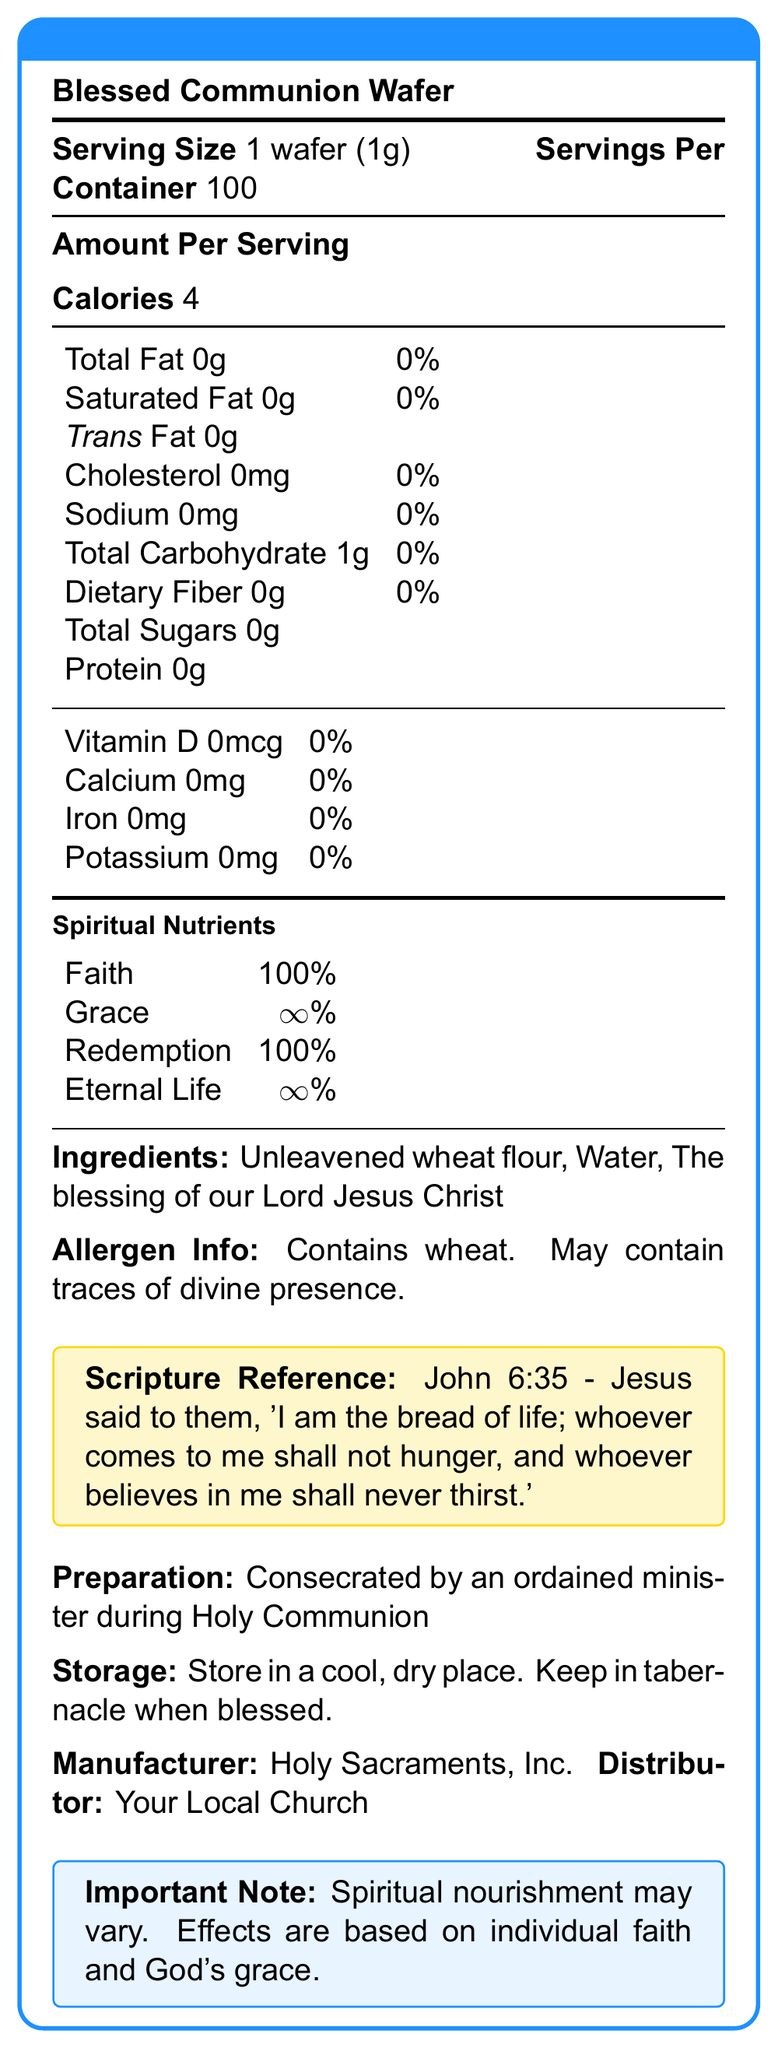what is the serving size of the Blessed Communion Wafer? The serving size is clearly mentioned in the document as 1 wafer (1g).
Answer: 1 wafer (1g) how many servings are there per container? The document states that there are 100 servings per container.
Answer: 100 how many calories are there per serving? The amount of calories per serving is given as 4.
Answer: 4 which vitamin is present in the Blessed Communion Wafer? The document lists all vitamins with a content of 0, indicating no vitamins are present.
Answer: None what is the % Daily Value of sodium per serving? The document shows that the % Daily Value of sodium per serving is 0%.
Answer: 0% what are the ingredients of the Blessed Communion Wafer? The ingredients are explicitly listed in the document.
Answer: Unleavened wheat flour, Water, The blessing of our Lord Jesus Christ which spiritual nutrient has the highest percentage? A. Faith B. Grace C. Redemption D. Eternal Life The document lists Grace with an ∞% percentage, which is the highest.
Answer: B. Grace how is the Blessed Communion Wafer prepared? A. By Baking B. By Boiling C. Consecration by an ordained minister D. Fermentation The document states that the wafer is consecrated by an ordained minister during Holy Communion.
Answer: C. Consecration by an ordained minister what is the scripture reference associated with the Blessed Communion Wafer? A. John 6:35 B. Matthew 5:9 C. Luke 22:19 D. Mark 14:22 The specified scripture reference in the document is John 6:35.
Answer: A. John 6:35 is the Blessed Communion Wafer free from allergens? The document mentions that it contains wheat and may contain traces of divine presence.
Answer: No does the Blessed Communion Wafer have any protein content? According to the document, the protein content per serving is 0g.
Answer: No what is the total carbohydrate content per serving? The total carbohydrate content per serving is listed as 1g.
Answer: 1g how should the Blessed Communion Wafer be stored once blessed? The document advises storing in a tabernacle when blessed.
Answer: Keep in tabernacle summarize the main idea of the document. The document is an overview of the Blessed Communion Wafer, describing its physical and spiritual components, and providing guidelines on preparation and storage while highlighting its religious significance.
Answer: The document provides detailed nutritional and spiritual information about the Blessed Communion Wafer, including serving size, ingredients, preparation, storage, and associated scripture reference. It emphasizes the spiritual benefits such as Faith, Grace, Redemption, and Eternal Life. who is the distributor of the Blessed Communion Wafer? The document mentions that the distributor is Your Local Church.
Answer: Your Local Church what is the % daily value of total fat? The document lists the % daily value of total fat as 0%.
Answer: 0% what does the document say about the variability in spiritual nourishment? The document includes a note that spiritual nourishment may vary depending on individual faith and God's grace.
Answer: Spiritual nourishment may vary. Effects are based on individual faith and God's grace. is there any information on where the Blessed Communion Wafer is manufactured? The document mentions that the manufacturer is Holy Sacraments, Inc.
Answer: Yes what is the blessing mentioned in the ingredients list? The document lists "The blessing of our Lord Jesus Christ" among the ingredients.
Answer: The blessing of our Lord Jesus Christ how often should the Blessed Communion Wafer be consumed for optimal results? The document does not provide information on the frequency of consumption for optimal results.
Answer: Cannot be determined 